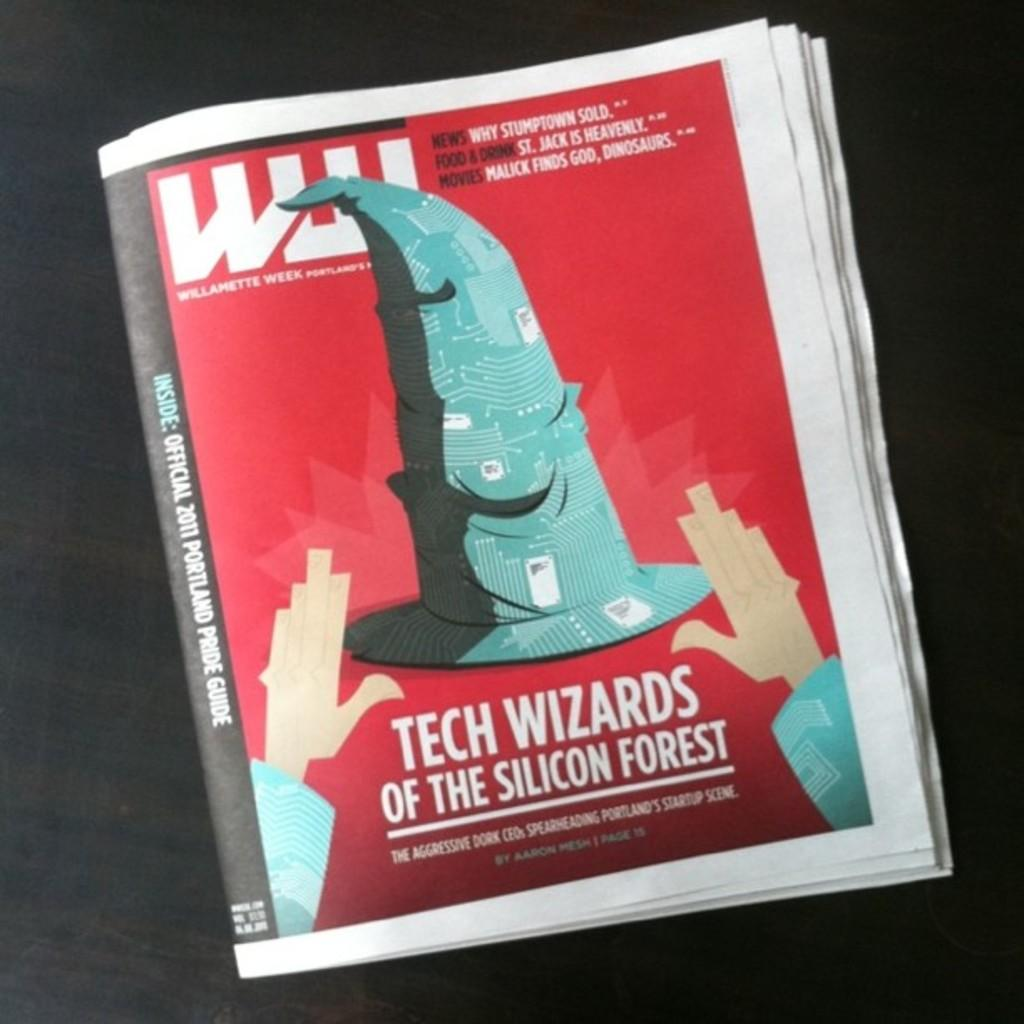<image>
Provide a brief description of the given image. paper named willamette week has cover story called tech wizards of the silicon forest 